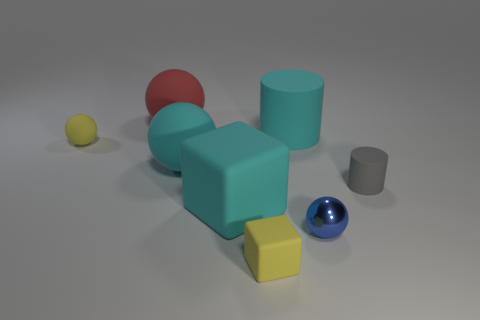There is a yellow matte object that is to the right of the small yellow rubber object that is behind the small metallic sphere; what is its size? The yellow matte object to the right of the yellow rubber object and behind the metallic sphere is relatively small in comparison to the other objects in the image, particularly when juxtaposed with the larger blue-gray cylinders. 